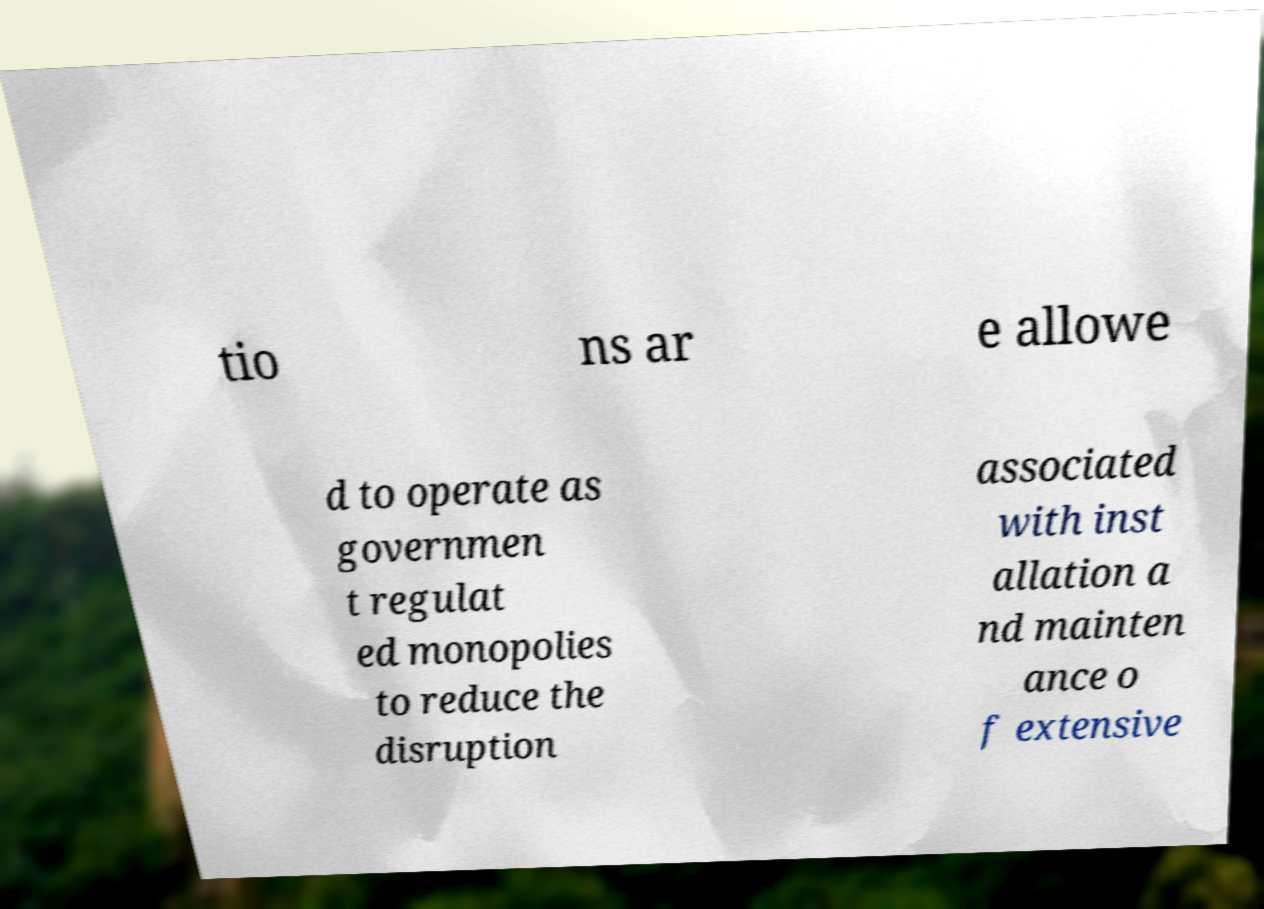Can you read and provide the text displayed in the image?This photo seems to have some interesting text. Can you extract and type it out for me? tio ns ar e allowe d to operate as governmen t regulat ed monopolies to reduce the disruption associated with inst allation a nd mainten ance o f extensive 